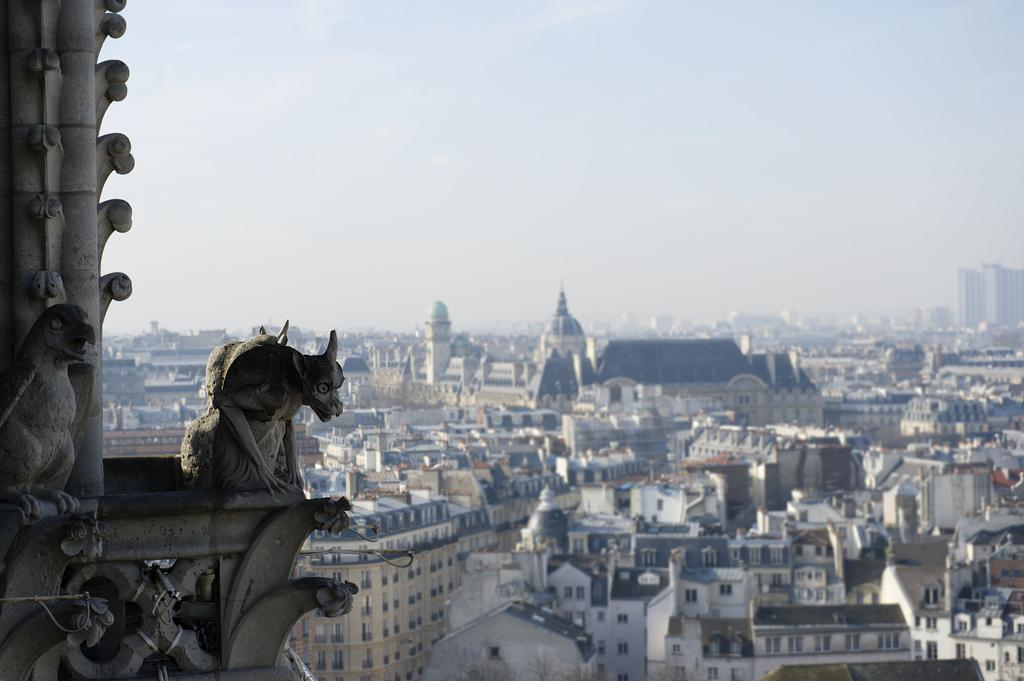What is the main focus of the image? The main focus of the image is the many buildings in the center. Are there any other notable features in the image? Yes, there is a sculpture on the left side of the image. What type of zebra can be seen in the scene on the right side of the image? There is no zebra present in the image; it only features buildings and a sculpture. 